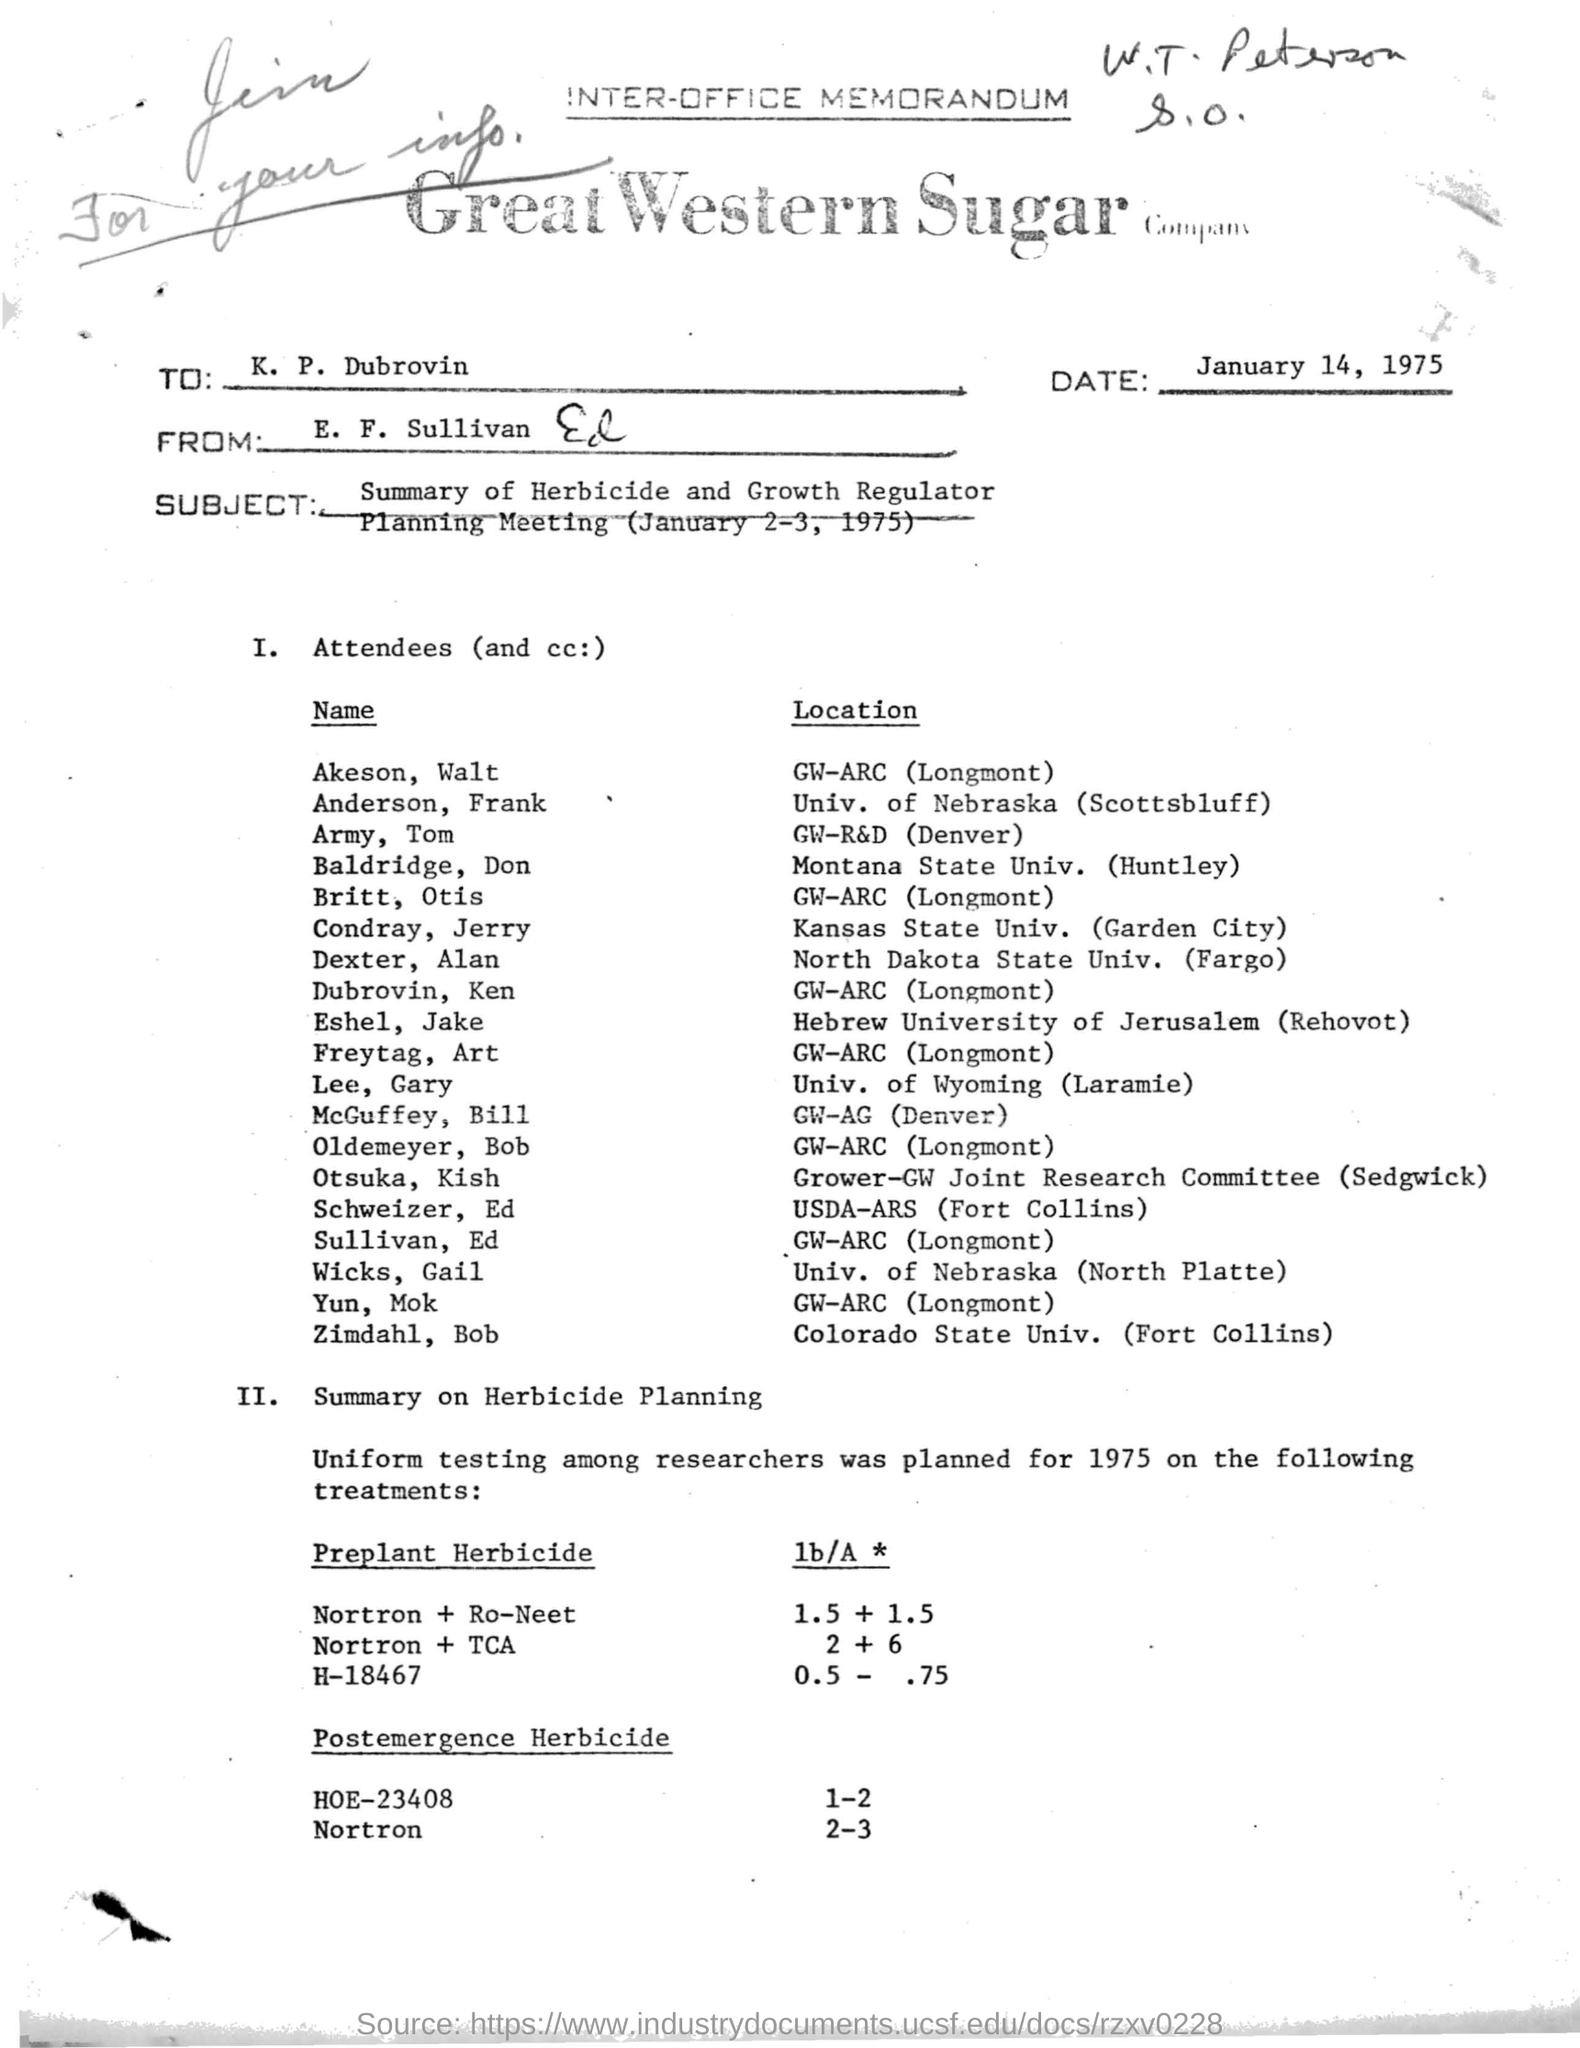What is written in top of the document ?
Offer a terse response. INTER-OFFICE MEMORANDUM. What is the Company Name ?
Your answer should be very brief. Great Western Sugar Company. What is the date mentioned in the top of the document ?
Keep it short and to the point. January 14, 1975. Who sent this ?
Your answer should be compact. E. F. Sullivan. Who is the recipient ?
Ensure brevity in your answer.  K. P. Dubrovin. What is the date mentioned in the Subject ?
Give a very brief answer. (January 2-3, 1975). What is the location of Akeson, Walt ?
Keep it short and to the point. GW-ARC  (Longmont). Which year Uniform testing among researches was planned ?
Offer a very short reply. 1975. 